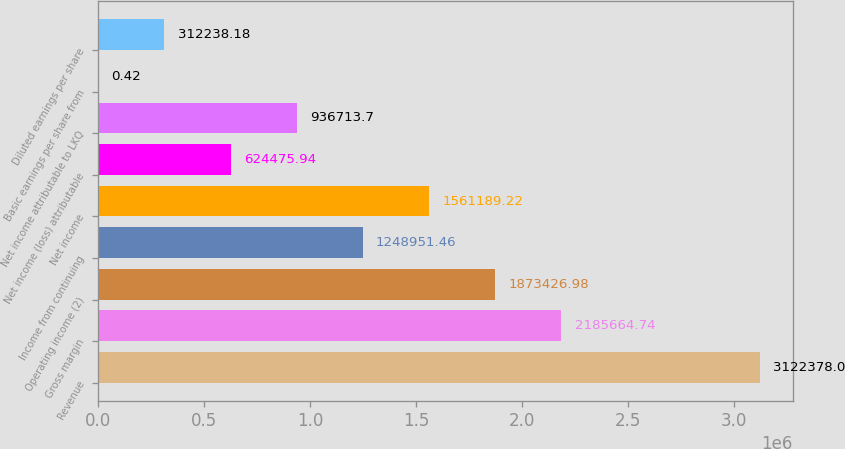Convert chart. <chart><loc_0><loc_0><loc_500><loc_500><bar_chart><fcel>Revenue<fcel>Gross margin<fcel>Operating income (2)<fcel>Income from continuing<fcel>Net income<fcel>Net income (loss) attributable<fcel>Net income attributable to LKQ<fcel>Basic earnings per share from<fcel>Diluted earnings per share<nl><fcel>3.12238e+06<fcel>2.18566e+06<fcel>1.87343e+06<fcel>1.24895e+06<fcel>1.56119e+06<fcel>624476<fcel>936714<fcel>0.42<fcel>312238<nl></chart> 